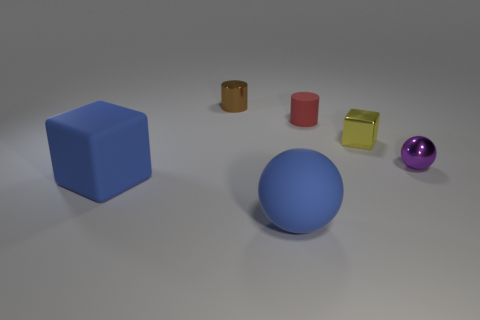Subtract all gray cylinders. Subtract all cyan blocks. How many cylinders are left? 2 Add 1 big blocks. How many objects exist? 7 Subtract all cylinders. How many objects are left? 4 Add 6 yellow metallic cubes. How many yellow metallic cubes are left? 7 Add 4 big gray matte cubes. How many big gray matte cubes exist? 4 Subtract 1 blue spheres. How many objects are left? 5 Subtract all cubes. Subtract all purple things. How many objects are left? 3 